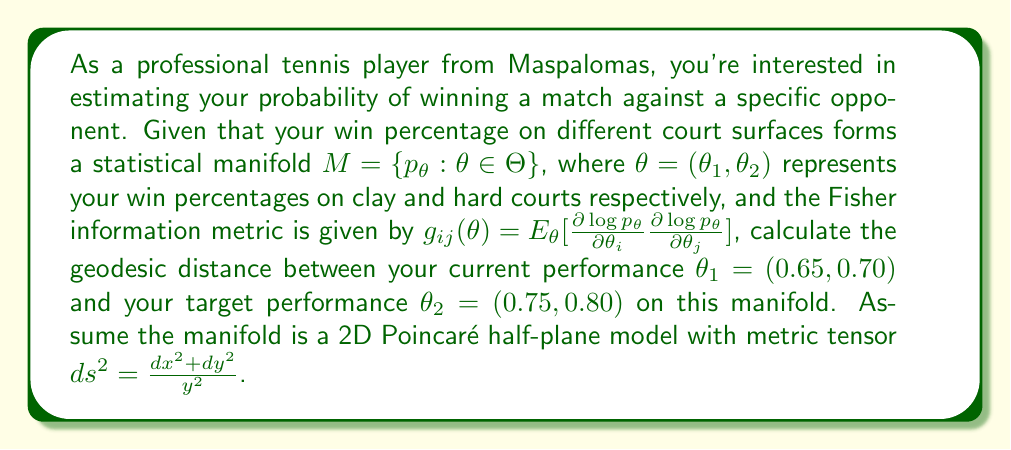Could you help me with this problem? To solve this problem, we'll use concepts from information geometry and the geometry of the Poincaré half-plane model. Here's a step-by-step approach:

1) First, we need to understand that the statistical manifold of win percentages can be represented as a Poincaré half-plane model. This model is a representation of hyperbolic geometry where the upper half of the complex plane represents the manifold.

2) In the Poincaré half-plane model, the metric tensor is given by:

   $$ds^2 = \frac{dx^2 + dy^2}{y^2}$$

3) The geodesic distance between two points $(x_1, y_1)$ and $(x_2, y_2)$ in this model is given by:

   $$d((x_1, y_1), (x_2, y_2)) = \text{arcosh}\left(1 + \frac{(x_2 - x_1)^2 + (y_2 - y_1)^2}{2y_1y_2}\right)$$

   where arcosh is the inverse hyperbolic cosine function.

4) In our case, we have:
   $(x_1, y_1) = (0.65, 0.70)$ (current performance)
   $(x_2, y_2) = (0.75, 0.80)$ (target performance)

5) Plugging these values into the geodesic distance formula:

   $$d = \text{arcosh}\left(1 + \frac{(0.75 - 0.65)^2 + (0.80 - 0.70)^2}{2 * 0.70 * 0.80}\right)$$

6) Simplifying:

   $$d = \text{arcosh}\left(1 + \frac{0.1^2 + 0.1^2}{1.12}\right)$$
   $$d = \text{arcosh}\left(1 + \frac{0.02}{1.12}\right)$$
   $$d = \text{arcosh}(1.017857143)$$

7) Calculating the final result:

   $$d \approx 0.1880$$

This geodesic distance represents the "shortest path" between your current performance and target performance on the statistical manifold of win percentages. A smaller distance indicates that the target is more achievable, while a larger distance suggests it may be more challenging to reach the target performance.
Answer: The geodesic distance between the current performance and target performance on the statistical manifold is approximately 0.1880. 